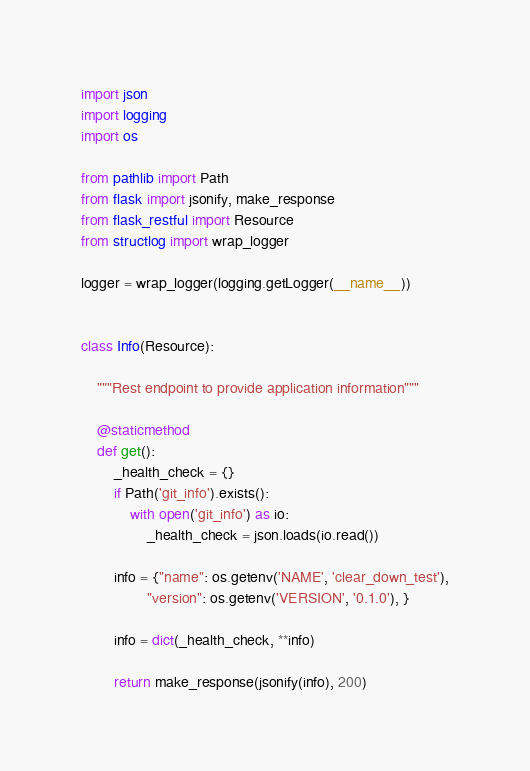<code> <loc_0><loc_0><loc_500><loc_500><_Python_>import json
import logging
import os

from pathlib import Path
from flask import jsonify, make_response
from flask_restful import Resource
from structlog import wrap_logger

logger = wrap_logger(logging.getLogger(__name__))


class Info(Resource):

    """Rest endpoint to provide application information"""

    @staticmethod
    def get():
        _health_check = {}
        if Path('git_info').exists():
            with open('git_info') as io:
                _health_check = json.loads(io.read())

        info = {"name": os.getenv('NAME', 'clear_down_test'),
                "version": os.getenv('VERSION', '0.1.0'), }

        info = dict(_health_check, **info)

        return make_response(jsonify(info), 200)
</code> 